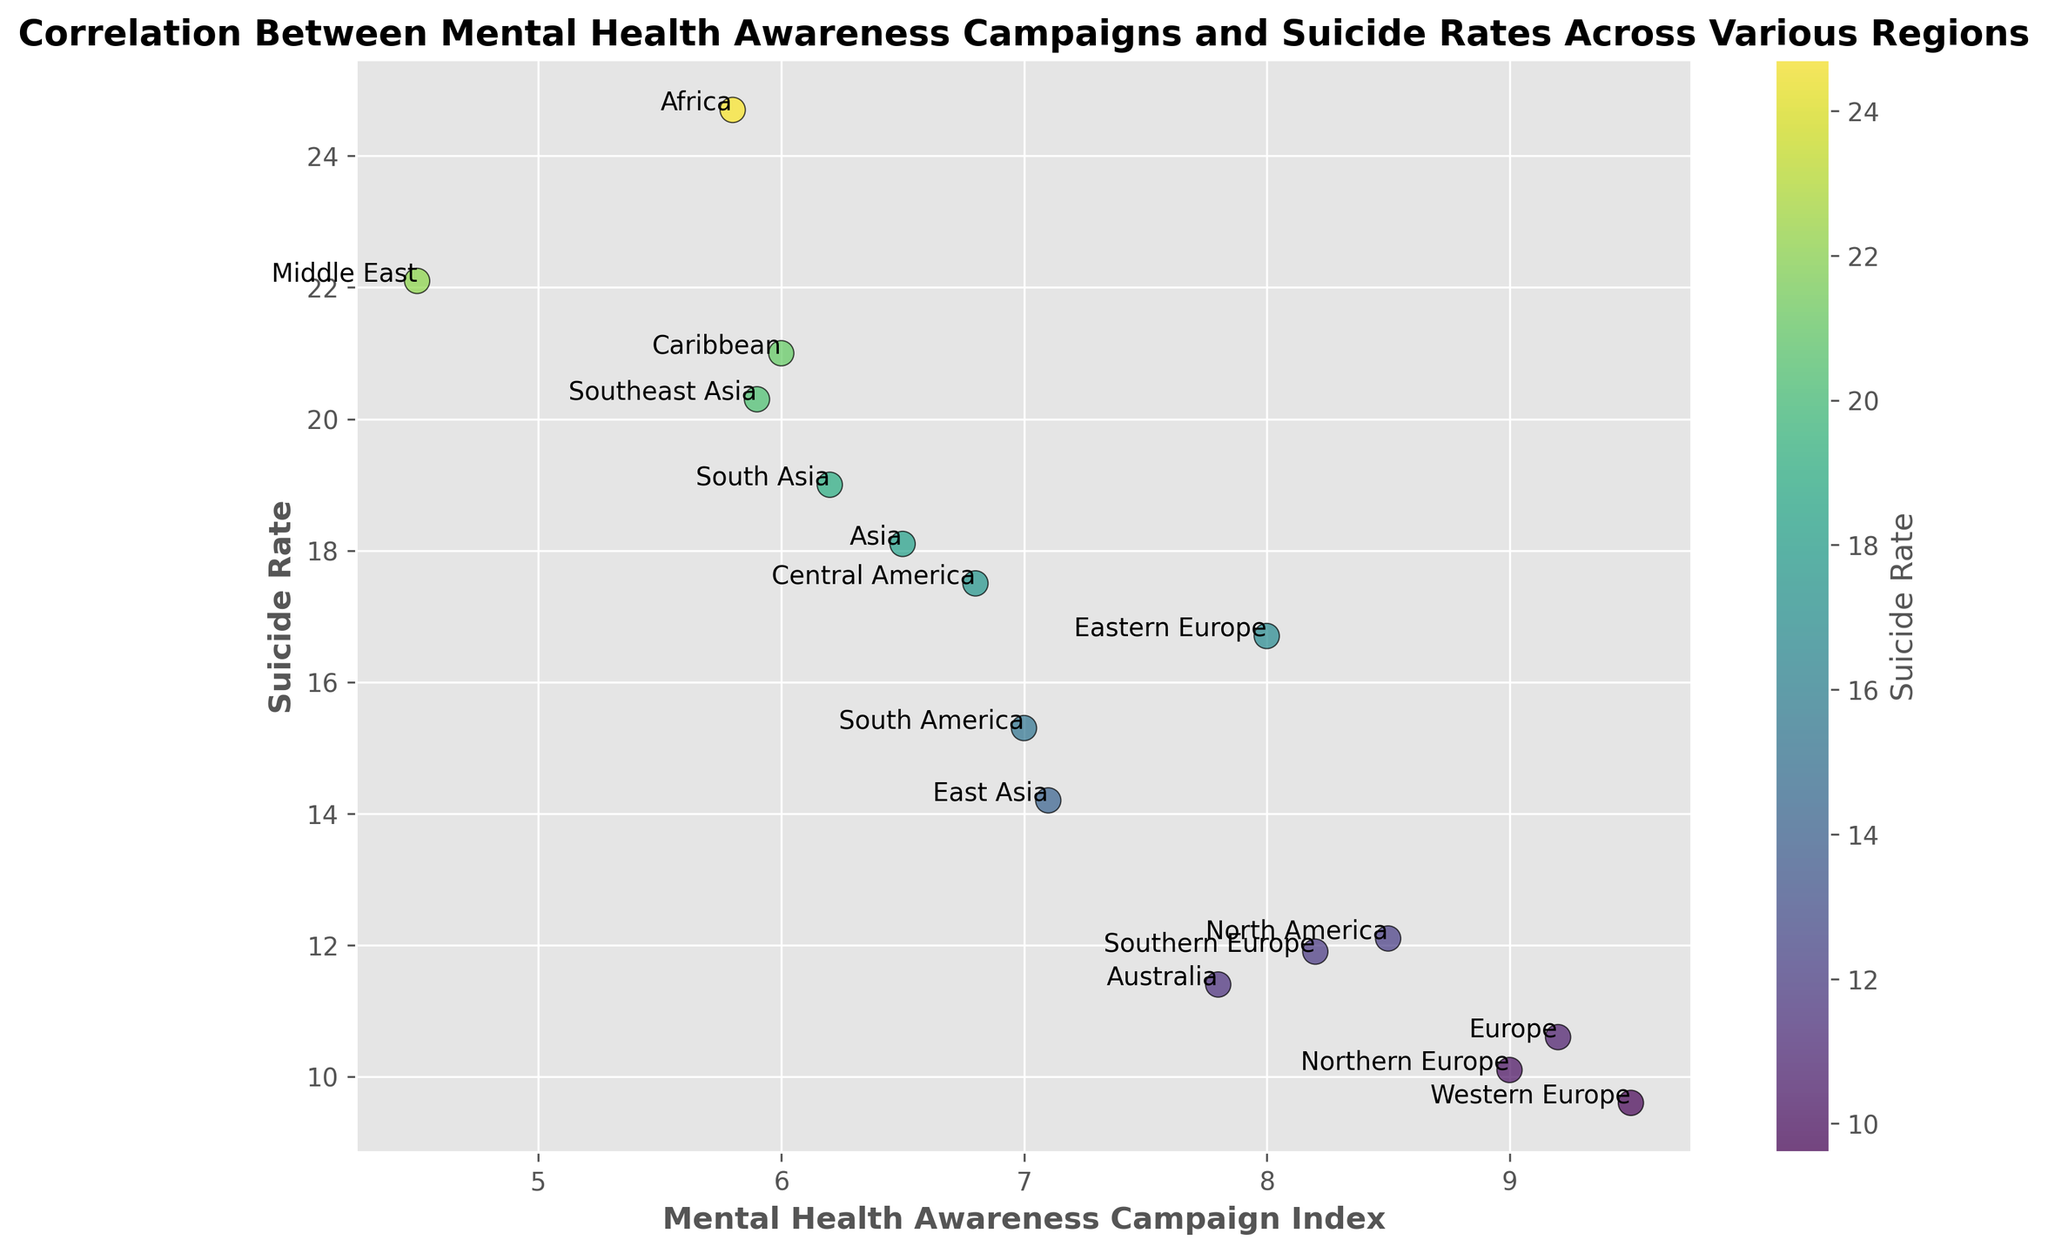What's the region with the highest suicide rate? The region with the highest suicide rate can be identified by locating the point with the maximum value on the y-axis. Based on the figure, the point with the highest suicide rate is in Africa, with a value of 24.7.
Answer: Africa What's the region with the lowest mental health awareness campaign index? The region with the lowest mental health awareness campaign index can be identified by locating the point with the minimum value on the x-axis. Based on the figure, the point with the lowest mental health awareness campaign index is in the Middle East, with a value of 4.5.
Answer: Middle East Which two regions have suicide rates closest to each other? To determine which two regions have suicide rates closest to each other, we need to find the two points on the plot where the y-values are almost the same. Upon inspection, Northern Europe (10.1) and Western Europe (9.6) have very close suicide rates.
Answer: Northern Europe and Western Europe Is there a correlation between mental health awareness campaigns and suicide rates? To determine if there's a correlation, observe the overall trend of the points. If the points show a pattern such as a negative or positive slope, a correlation may exist. The points on the graph show a general trend where higher mental health awareness indices often align with lower suicide rates, indicating a negative correlation.
Answer: Yes, negative correlation Which region has a higher suicide rate: South Asia or Southeast Asia? By comparing the y-values for South Asia and Southeast Asia on the plot, South Asia has a suicide rate of 19.0, whereas Southeast Asia has a suicide rate of 20.3. Therefore, Southeast Asia has a higher suicide rate.
Answer: Southeast Asia What is the suicide rate difference between Australia and South America? To find the difference, subtract the suicide rate of Australia (11.4) from that of South America (15.3). The difference is 15.3 - 11.4 = 3.9.
Answer: 3.9 Which two regions have the highest mental health awareness campaign index? To find the regions with the highest index, identify the two points with the highest values on the x-axis. Western Europe (9.5) and Europe (9.2) have the highest indices.
Answer: Western Europe and Europe How does the suicide rate in Central America compare to the global average suicide rate in the plot? First, calculate the average suicide rate across all regions depicted. Sum all suicide rates and divide by the number of regions. Then compare Central America's rate (17.5) to this average.
Answer: Above the average What is the average mental health awareness campaign index for the regions with a suicide rate lower than 15? Identify regions with a suicide rate lower than 15: North America (8.5), Europe (9.2), Australia (7.8), Eastern Europe (8.0), Western Europe (9.5), Northern Europe (9.0), and Southern Europe (8.2). Calculate the average index of these values: (8.5 + 9.2 + 7.8 + 8.0 + 9.5 + 9.0 + 8.2) / 7 = 8.6.
Answer: 8.6 